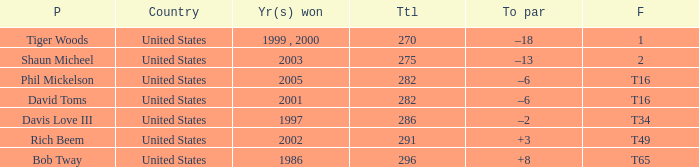In what place did Phil Mickelson finish with a total of 282? T16. 